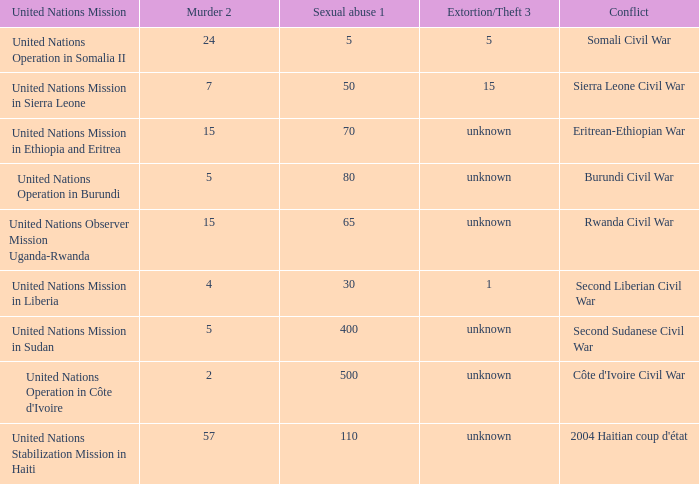What is the extortion and theft rates where the United Nations Observer Mission Uganda-Rwanda is active? Unknown. 